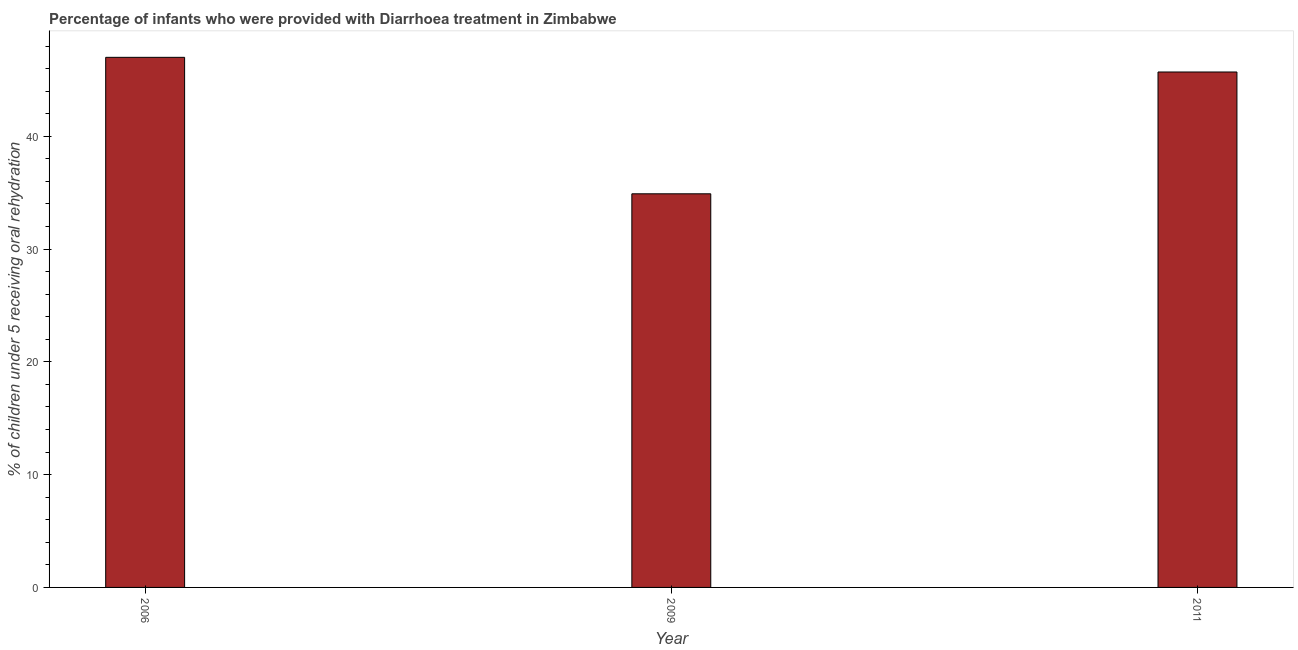What is the title of the graph?
Provide a succinct answer. Percentage of infants who were provided with Diarrhoea treatment in Zimbabwe. What is the label or title of the Y-axis?
Keep it short and to the point. % of children under 5 receiving oral rehydration. What is the percentage of children who were provided with treatment diarrhoea in 2011?
Provide a succinct answer. 45.7. Across all years, what is the maximum percentage of children who were provided with treatment diarrhoea?
Your response must be concise. 47. Across all years, what is the minimum percentage of children who were provided with treatment diarrhoea?
Make the answer very short. 34.9. In which year was the percentage of children who were provided with treatment diarrhoea maximum?
Give a very brief answer. 2006. What is the sum of the percentage of children who were provided with treatment diarrhoea?
Make the answer very short. 127.6. What is the difference between the percentage of children who were provided with treatment diarrhoea in 2009 and 2011?
Provide a short and direct response. -10.8. What is the average percentage of children who were provided with treatment diarrhoea per year?
Your response must be concise. 42.53. What is the median percentage of children who were provided with treatment diarrhoea?
Offer a terse response. 45.7. In how many years, is the percentage of children who were provided with treatment diarrhoea greater than 36 %?
Ensure brevity in your answer.  2. What is the ratio of the percentage of children who were provided with treatment diarrhoea in 2006 to that in 2011?
Keep it short and to the point. 1.03. Is the difference between the percentage of children who were provided with treatment diarrhoea in 2006 and 2011 greater than the difference between any two years?
Your answer should be compact. No. What is the difference between the highest and the second highest percentage of children who were provided with treatment diarrhoea?
Offer a very short reply. 1.3. Is the sum of the percentage of children who were provided with treatment diarrhoea in 2006 and 2009 greater than the maximum percentage of children who were provided with treatment diarrhoea across all years?
Your answer should be compact. Yes. What is the difference between the highest and the lowest percentage of children who were provided with treatment diarrhoea?
Offer a terse response. 12.1. In how many years, is the percentage of children who were provided with treatment diarrhoea greater than the average percentage of children who were provided with treatment diarrhoea taken over all years?
Offer a terse response. 2. How many years are there in the graph?
Your answer should be compact. 3. What is the % of children under 5 receiving oral rehydration of 2009?
Offer a terse response. 34.9. What is the % of children under 5 receiving oral rehydration of 2011?
Provide a short and direct response. 45.7. What is the difference between the % of children under 5 receiving oral rehydration in 2006 and 2011?
Offer a very short reply. 1.3. What is the ratio of the % of children under 5 receiving oral rehydration in 2006 to that in 2009?
Your answer should be compact. 1.35. What is the ratio of the % of children under 5 receiving oral rehydration in 2006 to that in 2011?
Make the answer very short. 1.03. What is the ratio of the % of children under 5 receiving oral rehydration in 2009 to that in 2011?
Your response must be concise. 0.76. 